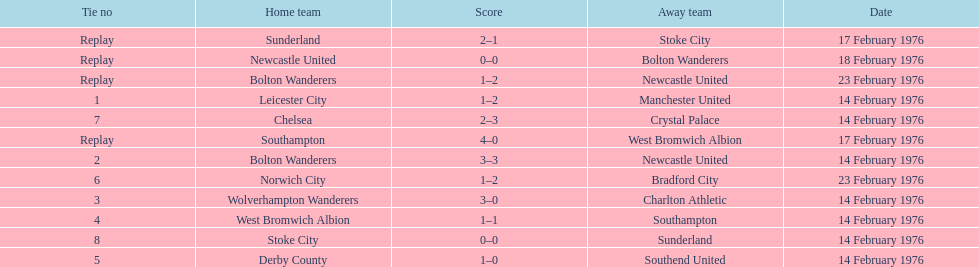Who had a better score, manchester united or wolverhampton wanderers? Wolverhampton Wanderers. 